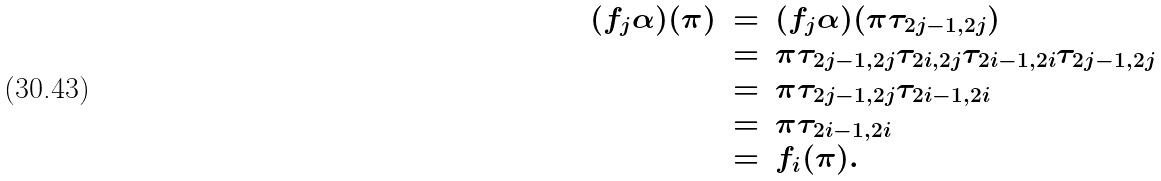<formula> <loc_0><loc_0><loc_500><loc_500>\begin{array} { r c l l } ( f _ { j } \alpha ) ( \pi ) & = & ( f _ { j } \alpha ) ( \pi \tau _ { 2 j - 1 , 2 j } ) \\ & = & \pi \tau _ { 2 j - 1 , 2 j } \tau _ { 2 i , 2 j } \tau _ { 2 i - 1 , 2 i } \tau _ { 2 j - 1 , 2 j } \\ & = & \pi \tau _ { 2 j - 1 , 2 j } \tau _ { 2 i - 1 , 2 i } \\ & = & \pi \tau _ { 2 i - 1 , 2 i } \\ & = & f _ { i } ( \pi ) . \end{array}</formula> 